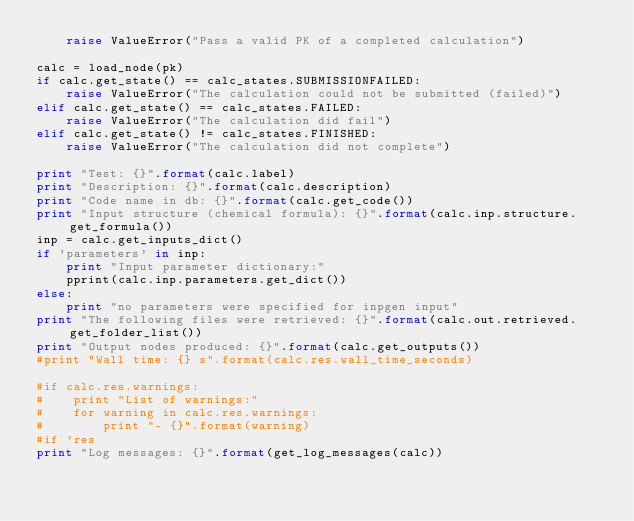<code> <loc_0><loc_0><loc_500><loc_500><_Python_>    raise ValueError("Pass a valid PK of a completed calculation")

calc = load_node(pk)
if calc.get_state() == calc_states.SUBMISSIONFAILED:
    raise ValueError("The calculation could not be submitted (failed)") 
elif calc.get_state() == calc_states.FAILED:
    raise ValueError("The calculation did fail")
elif calc.get_state() != calc_states.FINISHED:
    raise ValueError("The calculation did not complete")   

print "Test: {}".format(calc.label)
print "Description: {}".format(calc.description)
print "Code name in db: {}".format(calc.get_code())
print "Input structure (chemical formula): {}".format(calc.inp.structure.get_formula())
inp = calc.get_inputs_dict()
if 'parameters' in inp:
    print "Input parameter dictionary:"
    pprint(calc.inp.parameters.get_dict())
else:
    print "no parameters were specified for inpgen input"
print "The following files were retrieved: {}".format(calc.out.retrieved.get_folder_list())
print "Output nodes produced: {}".format(calc.get_outputs())
#print "Wall time: {} s".format(calc.res.wall_time_seconds)

#if calc.res.warnings:
#    print "List of warnings:"
#    for warning in calc.res.warnings:
#        print "- {}".format(warning)
#if 'res
print "Log messages: {}".format(get_log_messages(calc))        
  



</code> 